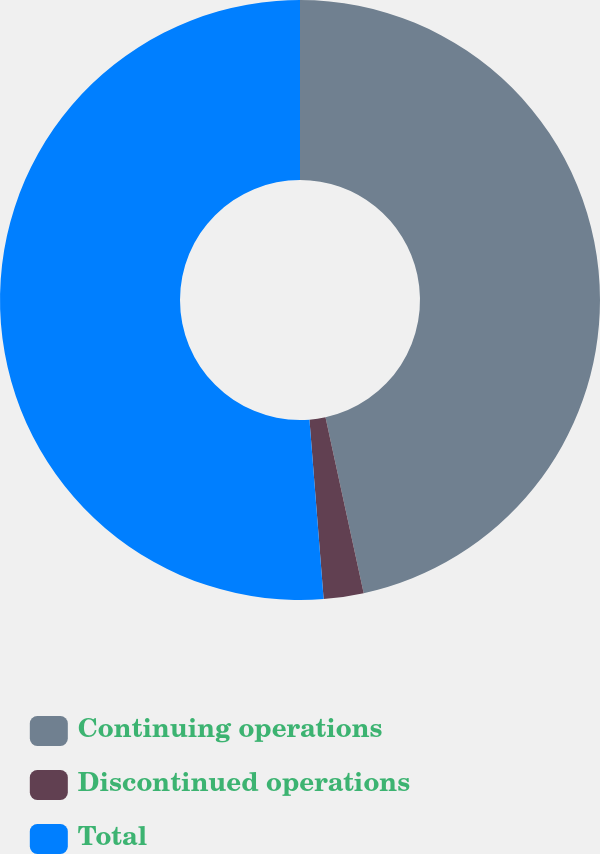<chart> <loc_0><loc_0><loc_500><loc_500><pie_chart><fcel>Continuing operations<fcel>Discontinued operations<fcel>Total<nl><fcel>46.59%<fcel>2.15%<fcel>51.25%<nl></chart> 